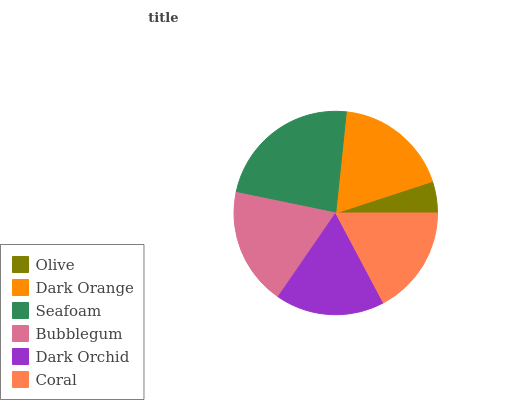Is Olive the minimum?
Answer yes or no. Yes. Is Seafoam the maximum?
Answer yes or no. Yes. Is Dark Orange the minimum?
Answer yes or no. No. Is Dark Orange the maximum?
Answer yes or no. No. Is Dark Orange greater than Olive?
Answer yes or no. Yes. Is Olive less than Dark Orange?
Answer yes or no. Yes. Is Olive greater than Dark Orange?
Answer yes or no. No. Is Dark Orange less than Olive?
Answer yes or no. No. Is Dark Orange the high median?
Answer yes or no. Yes. Is Dark Orchid the low median?
Answer yes or no. Yes. Is Bubblegum the high median?
Answer yes or no. No. Is Bubblegum the low median?
Answer yes or no. No. 